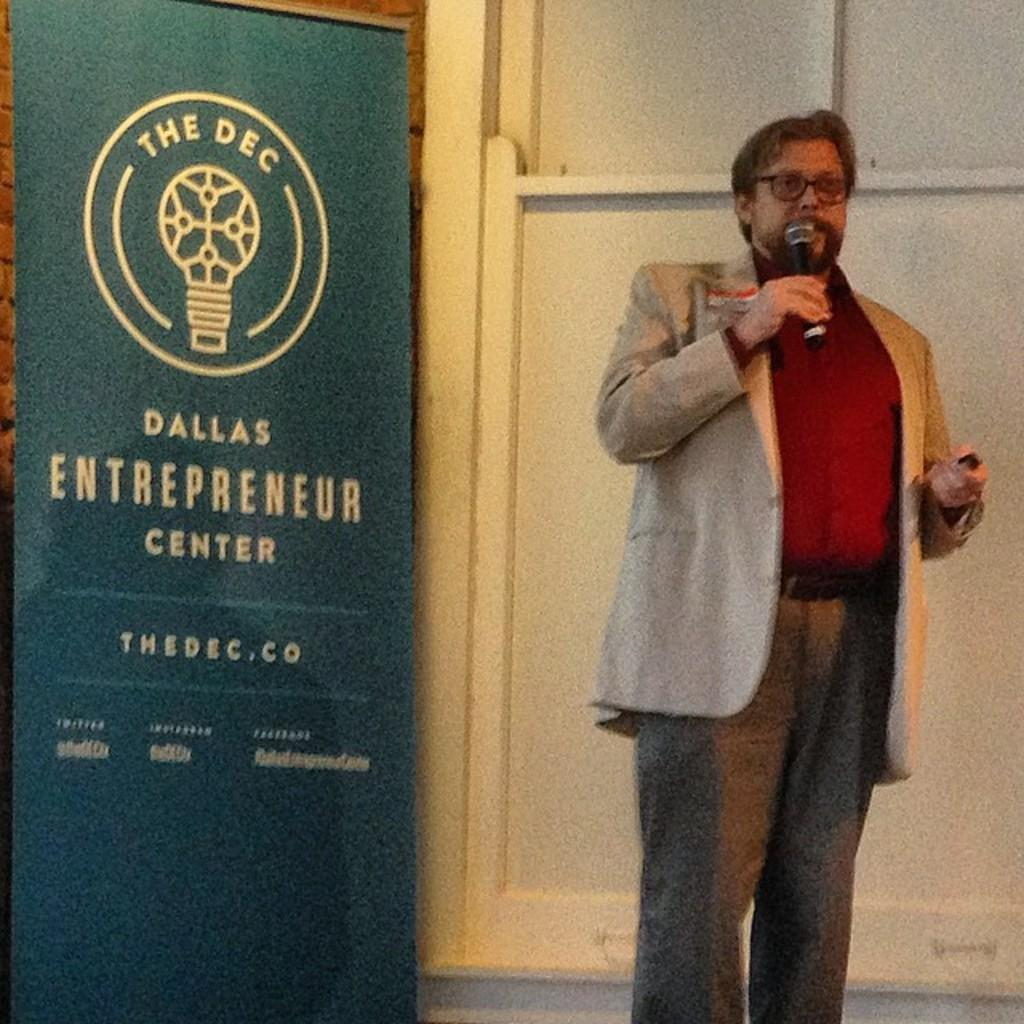<image>
Present a compact description of the photo's key features. A speaker gives a talk at the Dallas Entrepreneur Center. 